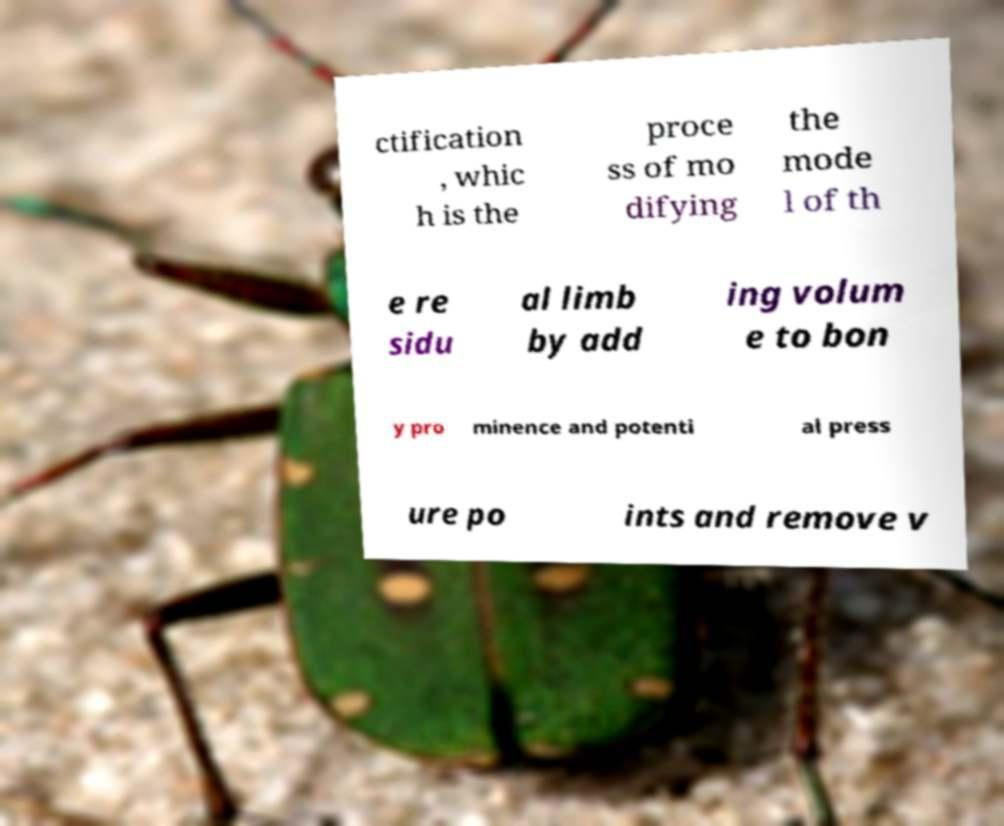Could you extract and type out the text from this image? ctification , whic h is the proce ss of mo difying the mode l of th e re sidu al limb by add ing volum e to bon y pro minence and potenti al press ure po ints and remove v 